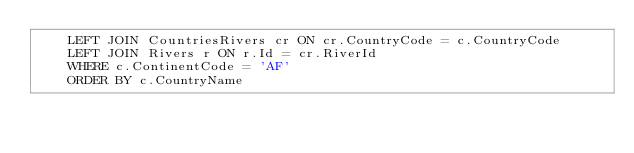Convert code to text. <code><loc_0><loc_0><loc_500><loc_500><_SQL_>	LEFT JOIN CountriesRivers cr ON cr.CountryCode = c.CountryCode
	LEFT JOIN Rivers r ON r.Id = cr.RiverId
	WHERE c.ContinentCode = 'AF'
	ORDER BY c.CountryName</code> 